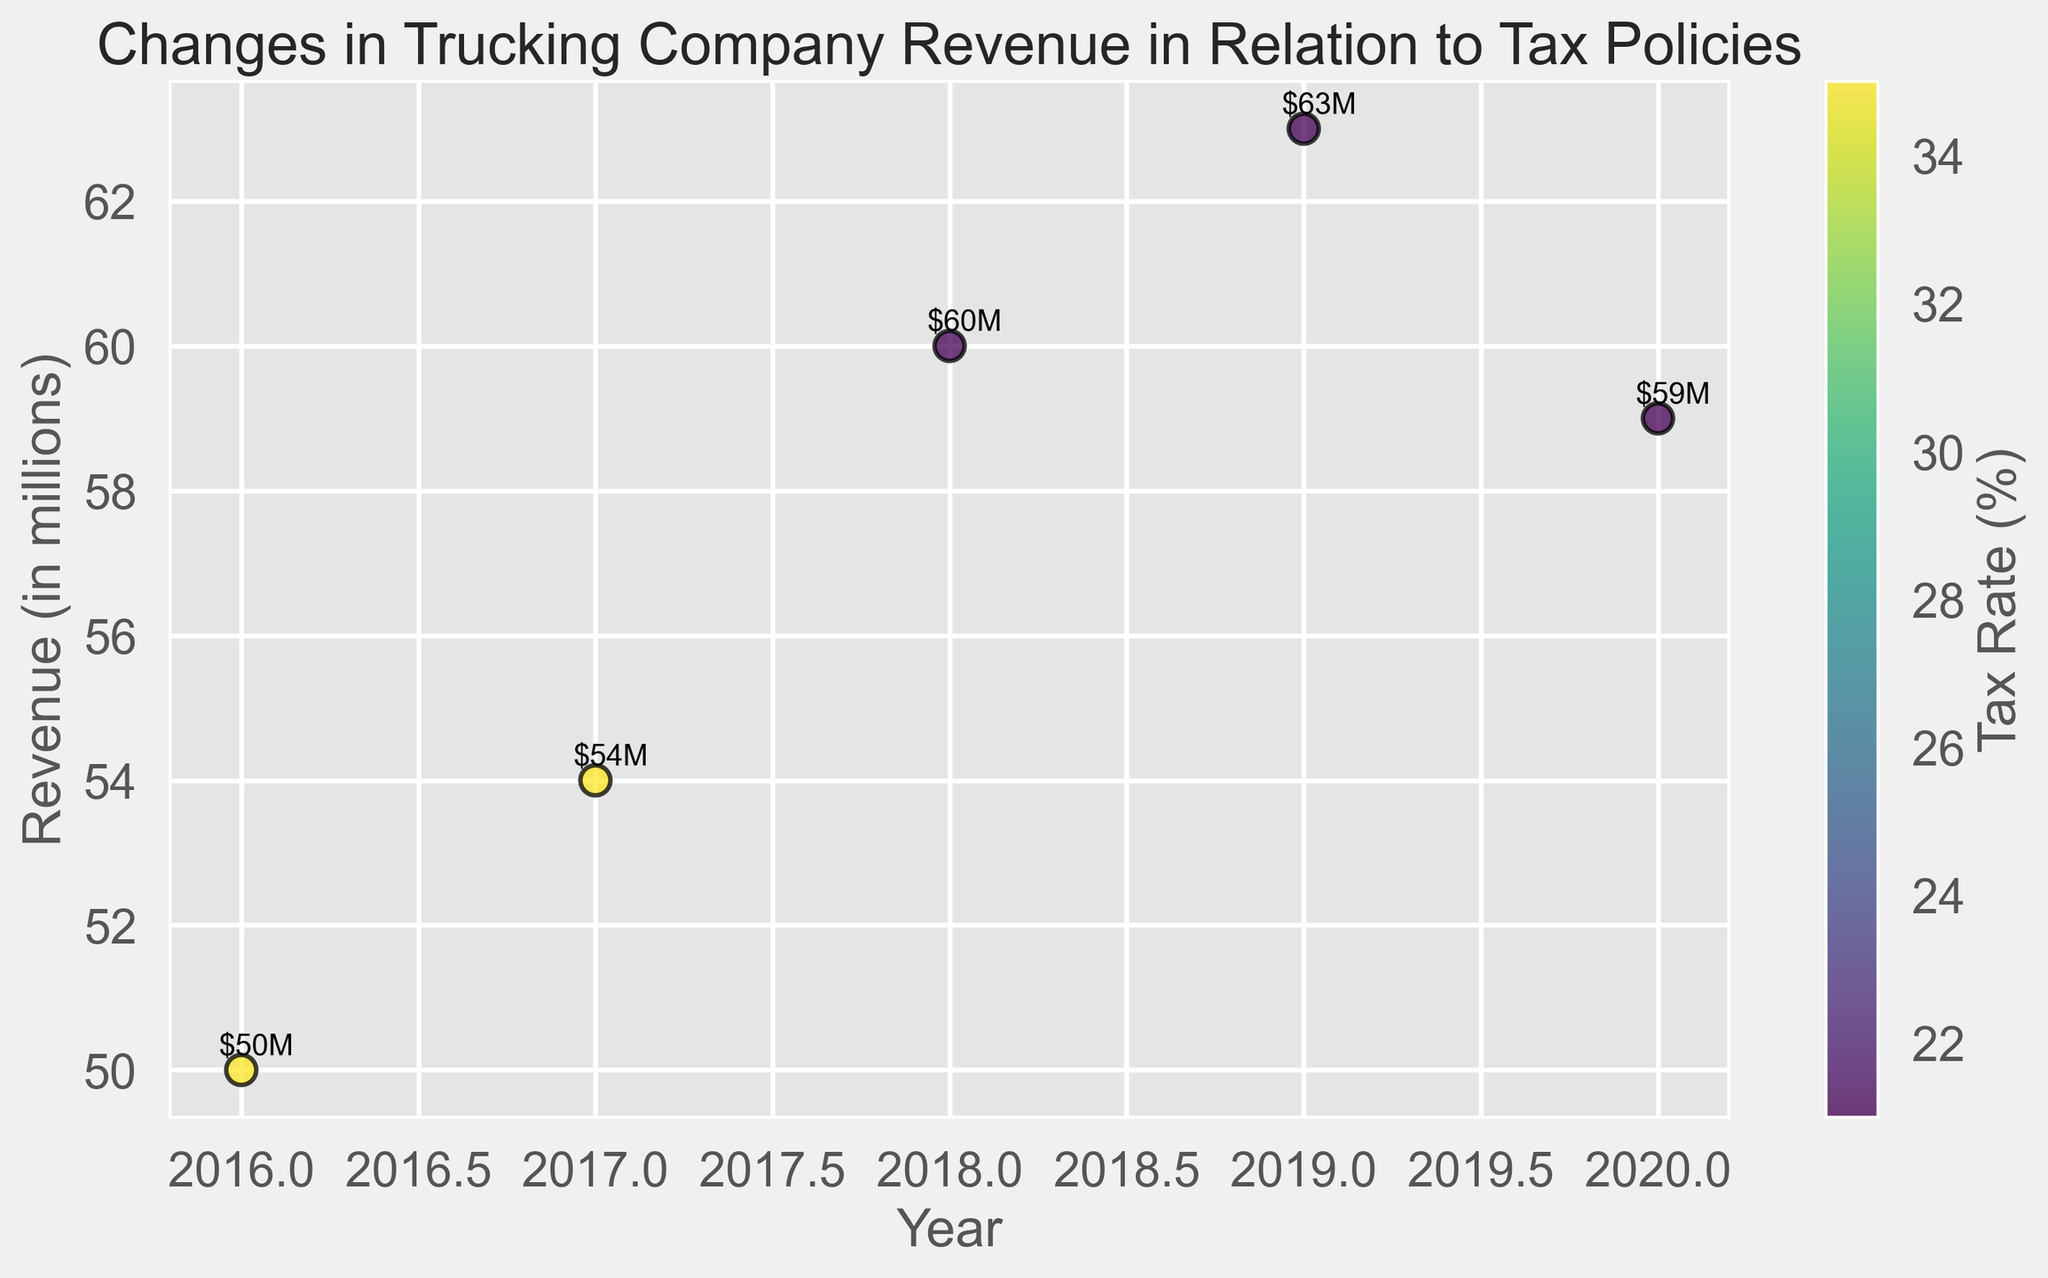What year had the highest revenue, and what was the tax rate in that year? Look at the scatter plot and identify the year with the highest vertical data point. The highest revenue (63 million) occurred in 2019, and the tax rate is indicated by color (21%).
Answer: 2019, 21% What is the revenue change from 2016 to 2018, and how did the tax rate change? Find the vertical position of data points for 2016 and 2018. The revenue went from 50 million in 2016 to 60 million in 2018, a difference of 10 million. The tax rate dropped from 35% in 2016 to 21% in 2018.
Answer: Increase by 10 million, tax rate decreased by 14% Which year is the tax rate the same and had a significant increase in revenue? Identify the years where the color representation of the tax rate remains the same but the vertical height (revenue) increases. From 2017 to 2018, the tax rate stayed at 35%, and revenue increased significantly from 54 to 60 million.
Answer: 2017-2018 How did revenue change from 2018 to 2020? Locate the data points for 2018 and 2020 then measure the vertical change. The revenue decreased from 60 million in 2018 to 59 million in 2020.
Answer: Decrease by 1 million What was the tax rate in 2016, and how does it compare to the tax rate in 2020? Examine the color-coded tax rates for 2016 and 2020. The tax rate was 35% in 2016 and 21% in 2020.
Answer: 35% in 2016, 21% in 2020 What is the average revenue over the years shown? Sum the revenue values and divide by the number of years. (50 + 54 + 60 + 63 + 59) / 5 = 286 / 5 = 57.2 million
Answer: 57.2 million From 2016 to 2020, how did revenue correlate with changes in the tax rate? Analyze data points from 2016 to 2020, noting changes and comparing trends. Initial low revenue aligns with higher tax rate, and reductions in tax rate generally coincide with revenue increases except for a minor decrease by 2020.
Answer: Generally increased with a tax rate decrease, slight decrease in 2020 